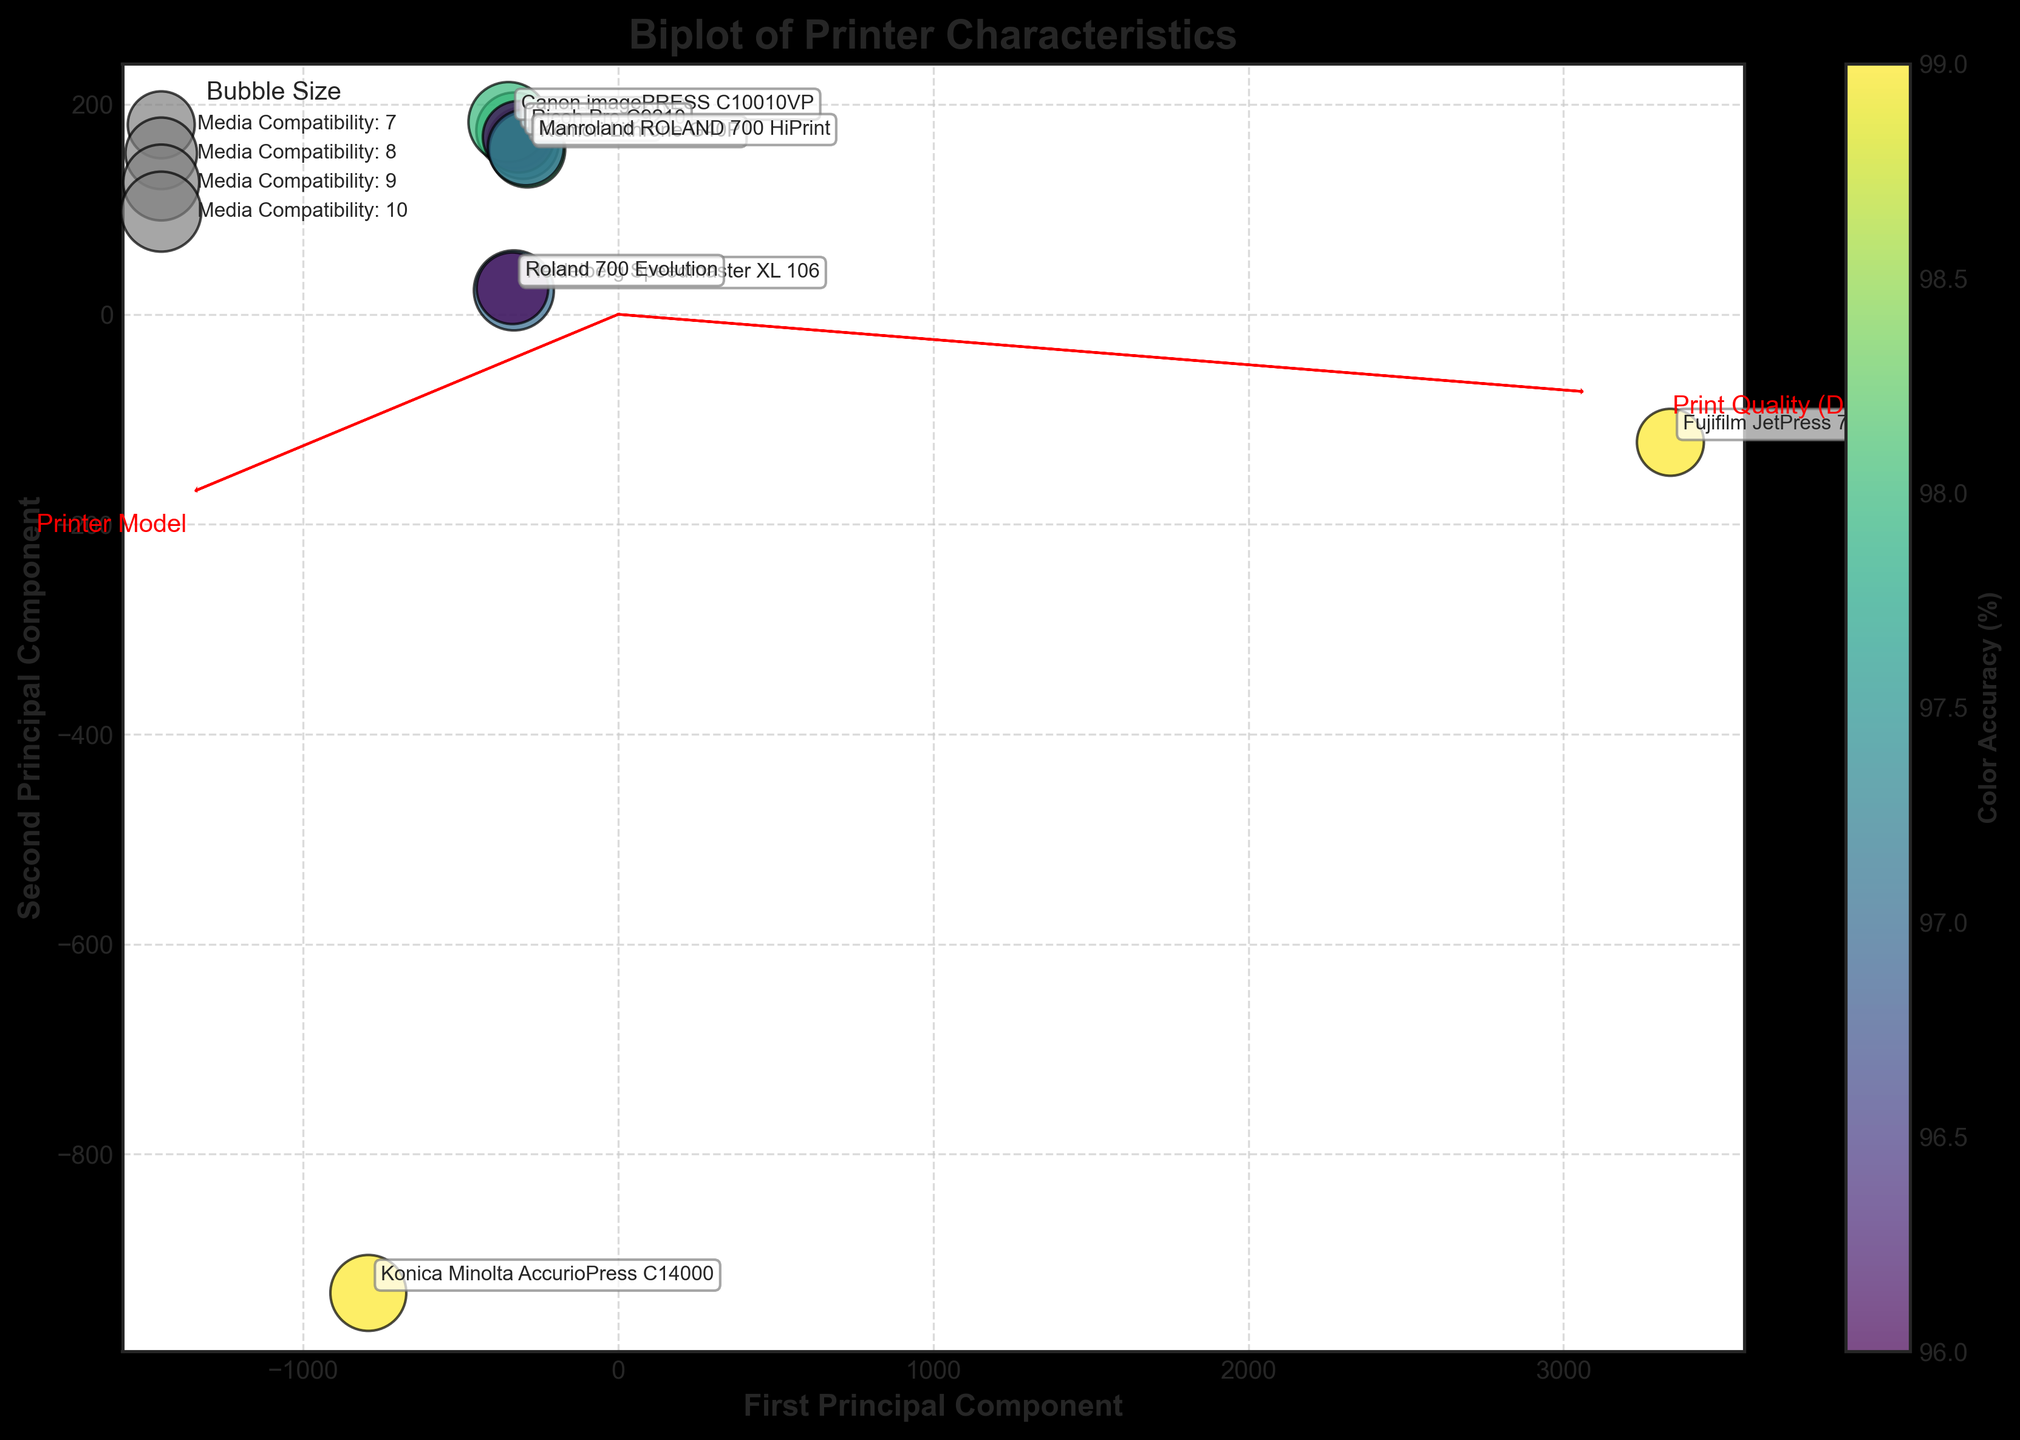How many printer models are plotted in the biplot? Count the number of distinct data points (scattered circles) in the plot, and each point represents a printer model.
Answer: 10 Which printer model has the highest Production Speed? Locate the data point that falls farthest along the axis representing Production Speed, and check its label.
Answer: Fujifilm JetPress 750S What is the trend between Print Quality and Production Speed? Observe the directions and lengths of the feature vectors corresponding to these two metrics. Check the alignment to understand the trend.
Answer: Direct relationship Which printer model has the highest Print Quality? Look for the data point projected farthest along the direction of the Print Quality vector and read its label.
Answer: Konica Minolta AccurioPress C14000 Which printer model has the lowest Color Accuracy? Identify the color of the data points corresponding to the color scale. The one with the darkest color has the lowest Color Accuracy.
Answer: Ricoh Pro C9210 and Roland 700 Evolution (both 96%) How is Media Compatibility Score visually represented in the plot? Notice the size of the bubbles/scatter points, which corresponds to the Media Compatibility Score. Refer to the legend for clarification.
Answer: Bubble size What does the arrow direction and length indicate in the context of this biplot? The arrow direction indicates the principal components' direction, and the length represents the contribution to the variance by that component.
Answer: Directions and Variance Which printer model offers the best overall balance between Print Quality and Production Speed? Observe data points close to both vector directions representing Print Quality and Production Speed. Look for proximity and balanced coordinates.
Answer: Xerox iGen 5 Considering both Color Accuracy and Media Compatibility Score, which printer model stands out? Identify the data point with the lightest color and the largest bubble size.
Answer: Canon imagePRESS C10010VP 